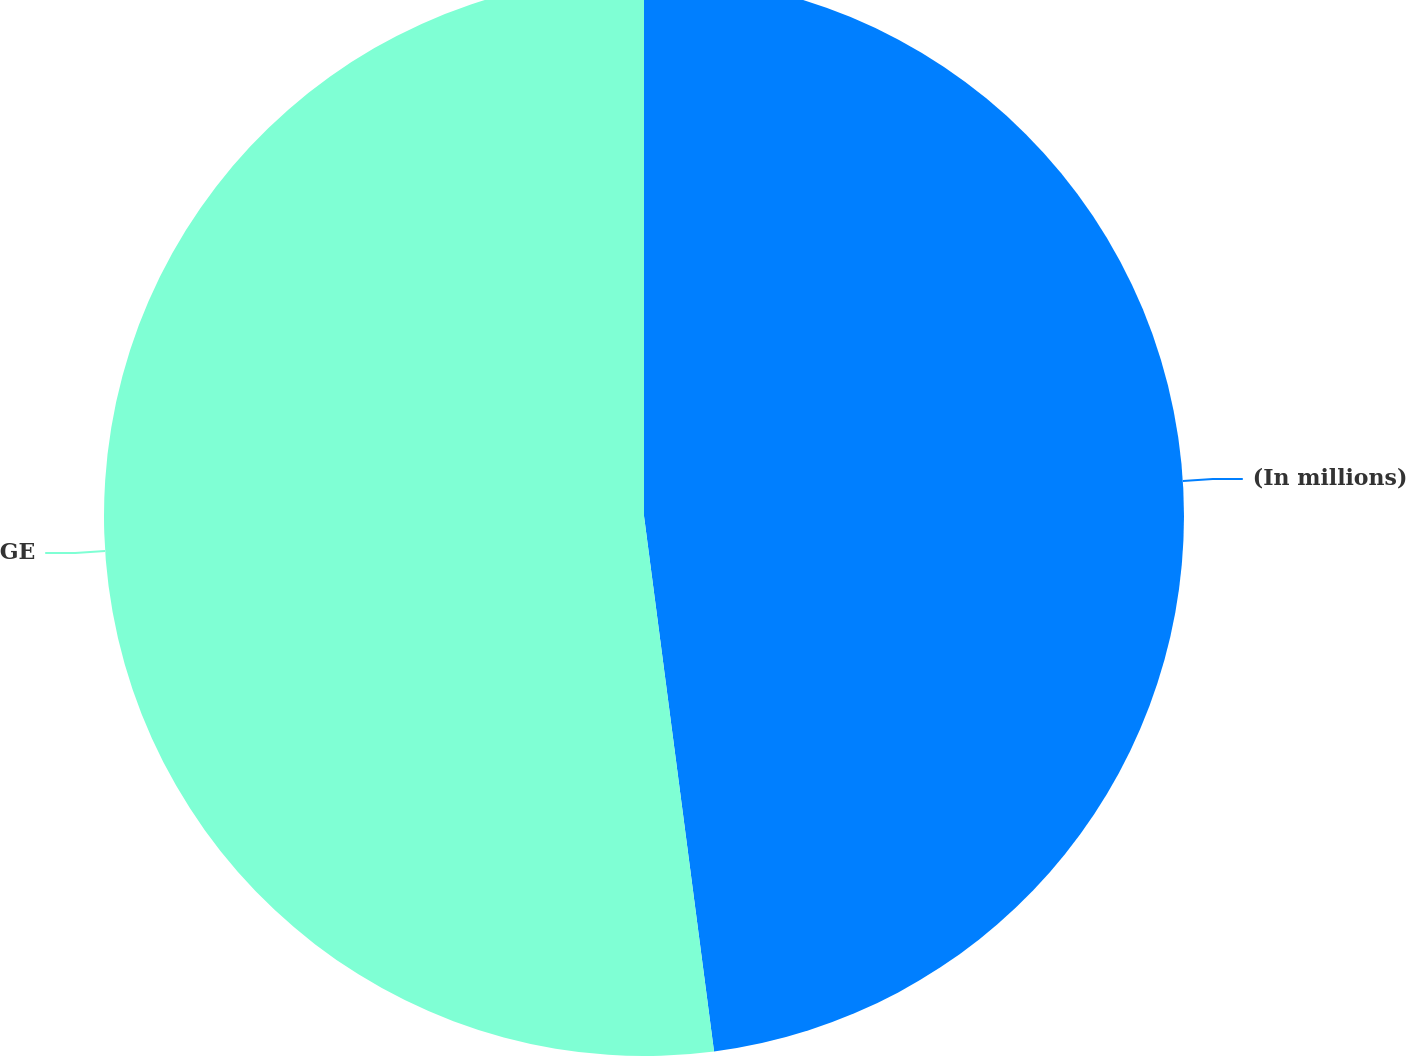Convert chart to OTSL. <chart><loc_0><loc_0><loc_500><loc_500><pie_chart><fcel>(In millions)<fcel>GE<nl><fcel>47.93%<fcel>52.07%<nl></chart> 